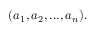<formula> <loc_0><loc_0><loc_500><loc_500>( a _ { 1 } , a _ { 2 } , \dots , a _ { n } ) .</formula> 